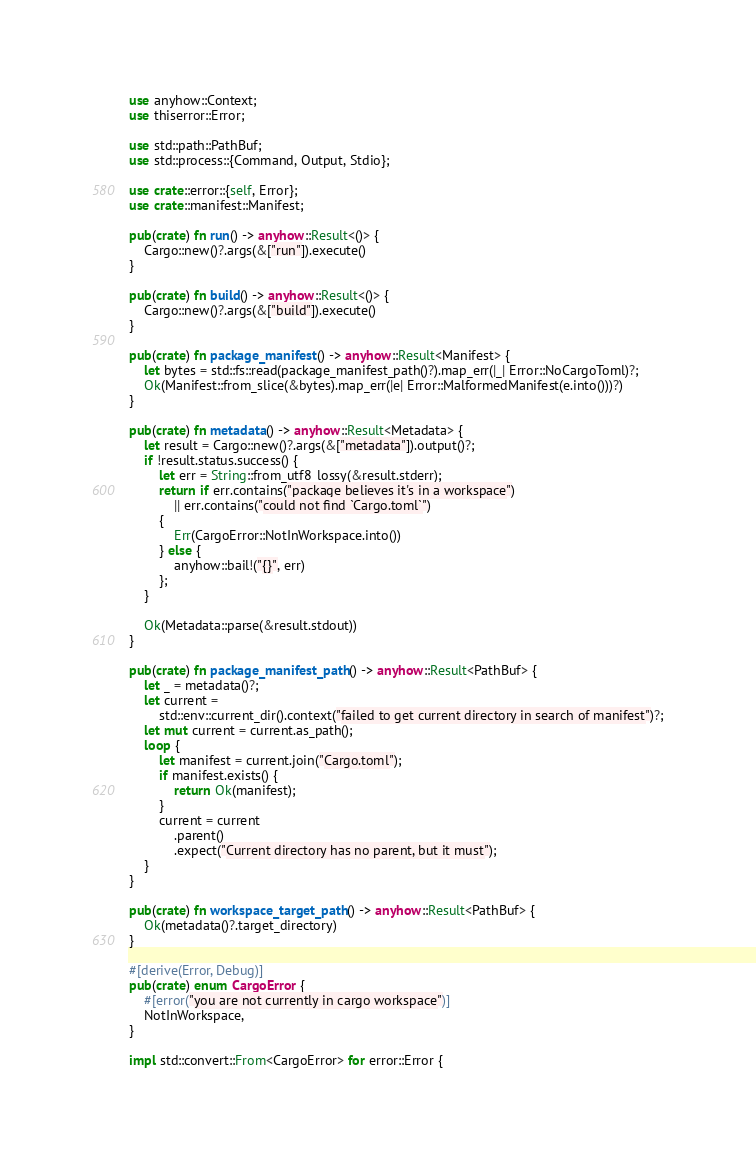Convert code to text. <code><loc_0><loc_0><loc_500><loc_500><_Rust_>use anyhow::Context;
use thiserror::Error;

use std::path::PathBuf;
use std::process::{Command, Output, Stdio};

use crate::error::{self, Error};
use crate::manifest::Manifest;

pub(crate) fn run() -> anyhow::Result<()> {
    Cargo::new()?.args(&["run"]).execute()
}

pub(crate) fn build() -> anyhow::Result<()> {
    Cargo::new()?.args(&["build"]).execute()
}

pub(crate) fn package_manifest() -> anyhow::Result<Manifest> {
    let bytes = std::fs::read(package_manifest_path()?).map_err(|_| Error::NoCargoToml)?;
    Ok(Manifest::from_slice(&bytes).map_err(|e| Error::MalformedManifest(e.into()))?)
}

pub(crate) fn metadata() -> anyhow::Result<Metadata> {
    let result = Cargo::new()?.args(&["metadata"]).output()?;
    if !result.status.success() {
        let err = String::from_utf8_lossy(&result.stderr);
        return if err.contains("package believes it's in a workspace")
            || err.contains("could not find `Cargo.toml`")
        {
            Err(CargoError::NotInWorkspace.into())
        } else {
            anyhow::bail!("{}", err)
        };
    }

    Ok(Metadata::parse(&result.stdout))
}

pub(crate) fn package_manifest_path() -> anyhow::Result<PathBuf> {
    let _ = metadata()?;
    let current =
        std::env::current_dir().context("failed to get current directory in search of manifest")?;
    let mut current = current.as_path();
    loop {
        let manifest = current.join("Cargo.toml");
        if manifest.exists() {
            return Ok(manifest);
        }
        current = current
            .parent()
            .expect("Current directory has no parent, but it must");
    }
}

pub(crate) fn workspace_target_path() -> anyhow::Result<PathBuf> {
    Ok(metadata()?.target_directory)
}

#[derive(Error, Debug)]
pub(crate) enum CargoError {
    #[error("you are not currently in cargo workspace")]
    NotInWorkspace,
}

impl std::convert::From<CargoError> for error::Error {</code> 